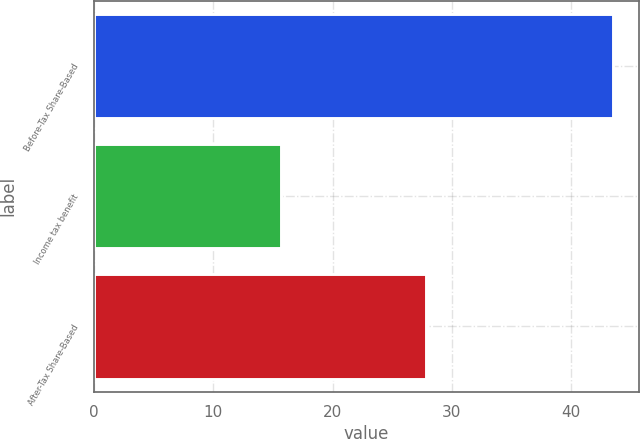Convert chart. <chart><loc_0><loc_0><loc_500><loc_500><bar_chart><fcel>Before-Tax Share-Based<fcel>Income tax benefit<fcel>After-Tax Share-Based<nl><fcel>43.5<fcel>15.7<fcel>27.8<nl></chart> 